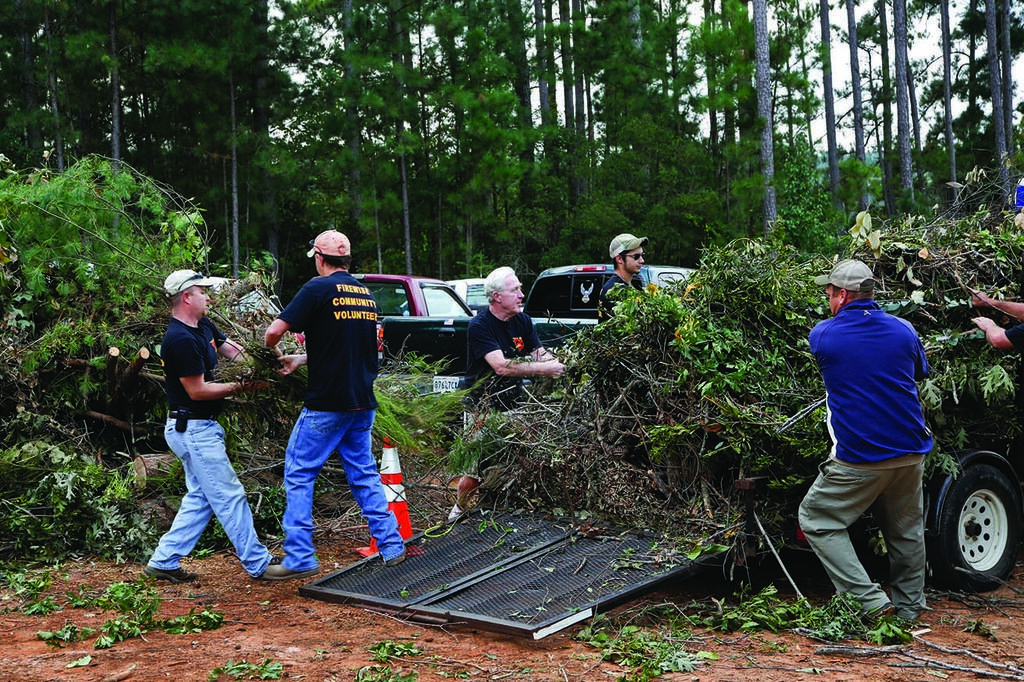In one or two sentences, can you explain what this image depicts? In this image there are few people. In the background here are trucks. Here there is a truck. They are putting cut trees on the truck. In the background there are trees. 